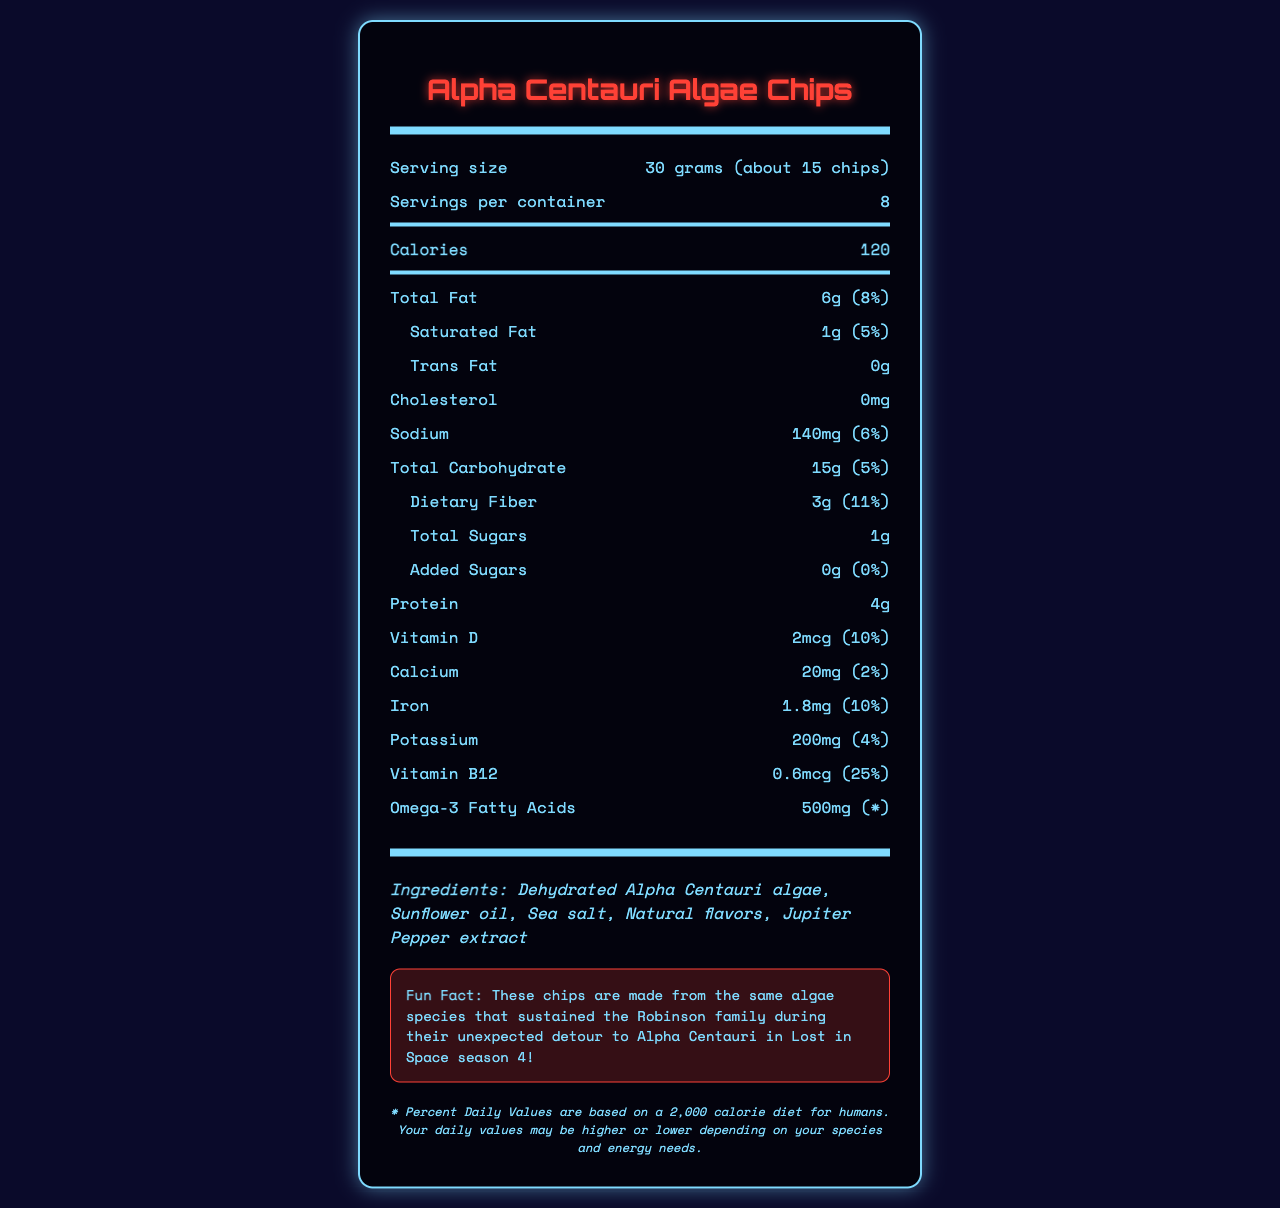what is the serving size of Alpha Centauri Algae Chips? The serving size is clearly listed as 30 grams or about 15 chips.
Answer: 30 grams (about 15 chips) how many calories are in one serving of Alpha Centauri Algae Chips? The calories per serving is specified to be 120.
Answer: 120 how much protein does one serving of Alpha Centauri Algae Chips contain? The amount of protein per serving is listed as 4 grams.
Answer: 4g is there any cholesterol in Alpha Centauri Algae Chips? The cholesterol content is listed as 0mg, meaning there is no cholesterol.
Answer: No what is the fun fact mentioned on the document? The fun fact section mentions this interesting tidbit about the connection to the Robinson family and Lost in Space.
Answer: These chips are made from the same algae species that sustained the Robinson family during their unexpected detour to Alpha Centauri in Lost in Space season 4! which of the following statements is true about the fiber content in Alpha Centauri Algae Chips? I. Dietary fiber is 3g, which is 11% daily value. II. Dietary fiber is not present. III. Fiber content information is missing. A. Only I B. Only II C. Only III The document clearly states that dietary fiber is 3g, which is 11% of the daily value.
Answer: A what percentage of the daily value for vitamin B12 does one serving of these chips provide? A. 25% B. 10% C. 5% D. 2% The document specifies that one serving provides 25% of the daily value for vitamin B12.
Answer: A how many servings are there in one container of Alpha Centauri Algae Chips? The servings per container is listed as 8.
Answer: 8 which ingredient is not part of Alpha Centauri Algae Chips? A. Dehydrated Alpha Centauri algae B. Sunflower oil C. Earth wheat flour D. Sea salt Earth wheat flour is not listed among the ingredients; the others are.
Answer: C does the document specify any allergens related to Alpha Centauri Algae Chips? The document mentions that the chips are manufactured in a facility that also processes Earth-based nuts and soy.
Answer: Yes summarize the nutrition information and facts about Alpha Centauri Algae Chips provided in this document. The summary captures the main points of the document, emphasizing the nutrition facts, ingredients, storage instructions, fun facts, and the disclaimer.
Answer: The document provides comprehensive nutritional details for Alpha Centauri Algae Chips, including serving size, calories, and various nutrient amounts such as fats, carbohydrates, protein, and vitamins. It highlights ingredients and allergens and includes a fun fact linking the product to the Lost in Space series. The document also notes serving instructions and a disclaimer about daily values based on a 2,000-calorie human diet. how does the sodium content in one serving of Alpha Centauri Algae Chips compare to its daily value percentage? The document lists the sodium content as 140mg, which constitutes 6% of the daily value.
Answer: 140mg, 6% is there any vitamin D in Alpha Centauri Algae Chips? The document specifies that there is 2mcg of vitamin D, accounting for 10% of the daily value.
Answer: Yes what company manufactures Alpha Centauri Algae Chips? The manufacturer is clearly listed as Galactic Snacks, Inc.
Answer: Galactic Snacks, Inc., a subsidiary of Jupiter Mining Corporation how long should Alpha Centauri Algae Chips be consumed after opening? The storage instructions specify that the chips should be consumed within 3 Earth weeks of opening.
Answer: Within 3 Earth weeks what is the origin of the natural flavors mentioned in the ingredient list? The document does not provide specific information about the origin of the natural flavors.
Answer: Cannot be determined 